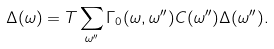<formula> <loc_0><loc_0><loc_500><loc_500>\Delta ( \omega ) = T \sum _ { \omega ^ { \prime \prime } } \Gamma _ { 0 } ( \omega , \omega ^ { \prime \prime } ) C ( \omega ^ { \prime \prime } ) \Delta ( \omega ^ { \prime \prime } ) .</formula> 